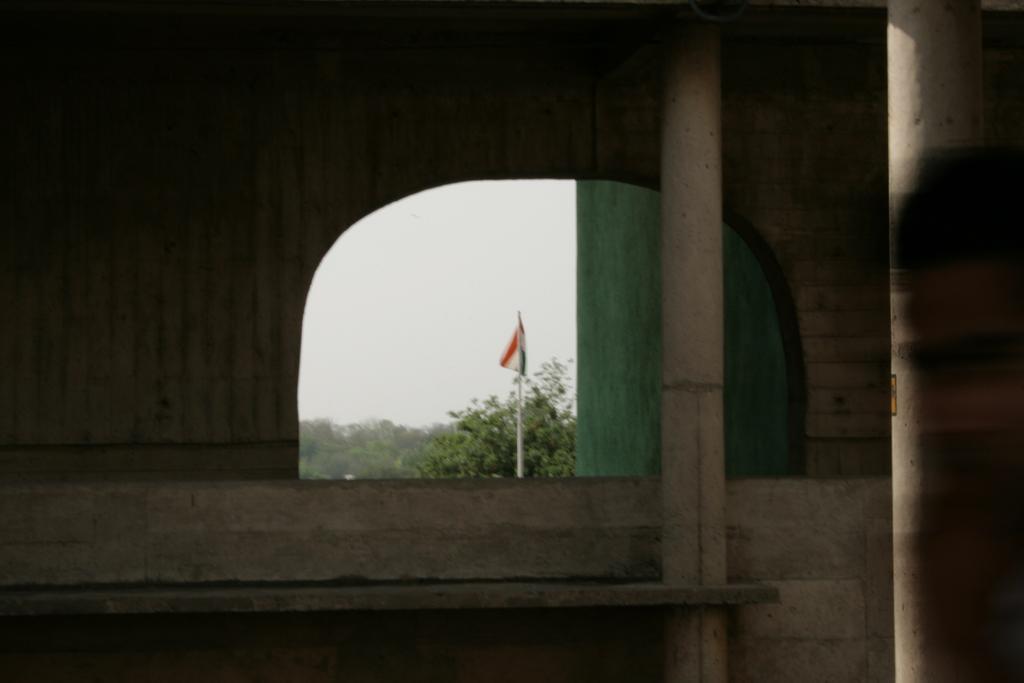Could you give a brief overview of what you see in this image? On the right side, we see a wall. At the bottom, we see the cement bench and a pole. On the left side, we see a wall. In the middle, we see the opening from which we can see the trees, flag pole and a flag in white, orange and green color. We even see the sky. 